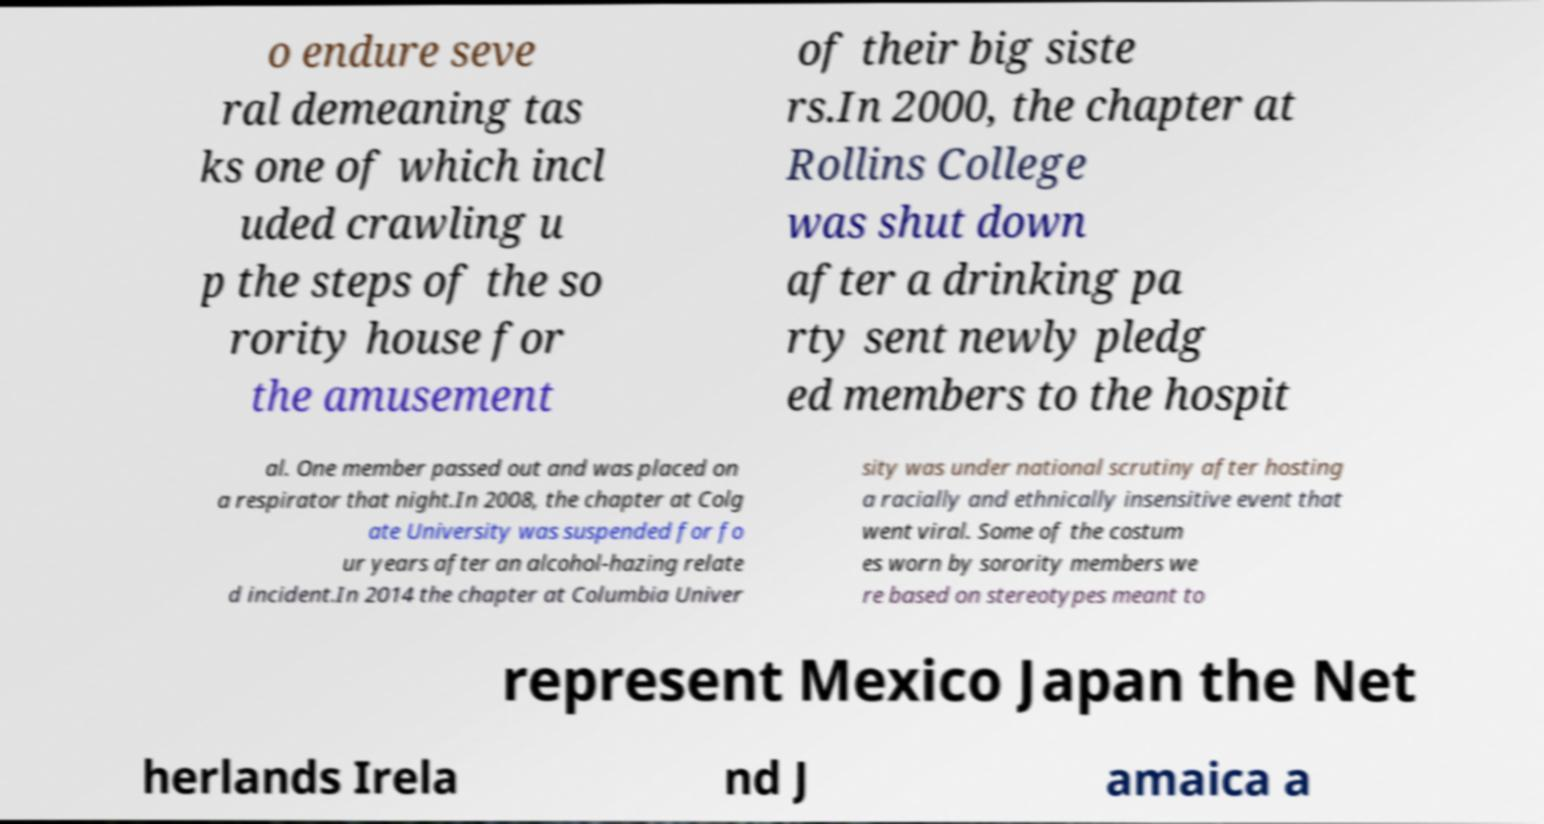For documentation purposes, I need the text within this image transcribed. Could you provide that? o endure seve ral demeaning tas ks one of which incl uded crawling u p the steps of the so rority house for the amusement of their big siste rs.In 2000, the chapter at Rollins College was shut down after a drinking pa rty sent newly pledg ed members to the hospit al. One member passed out and was placed on a respirator that night.In 2008, the chapter at Colg ate University was suspended for fo ur years after an alcohol-hazing relate d incident.In 2014 the chapter at Columbia Univer sity was under national scrutiny after hosting a racially and ethnically insensitive event that went viral. Some of the costum es worn by sorority members we re based on stereotypes meant to represent Mexico Japan the Net herlands Irela nd J amaica a 